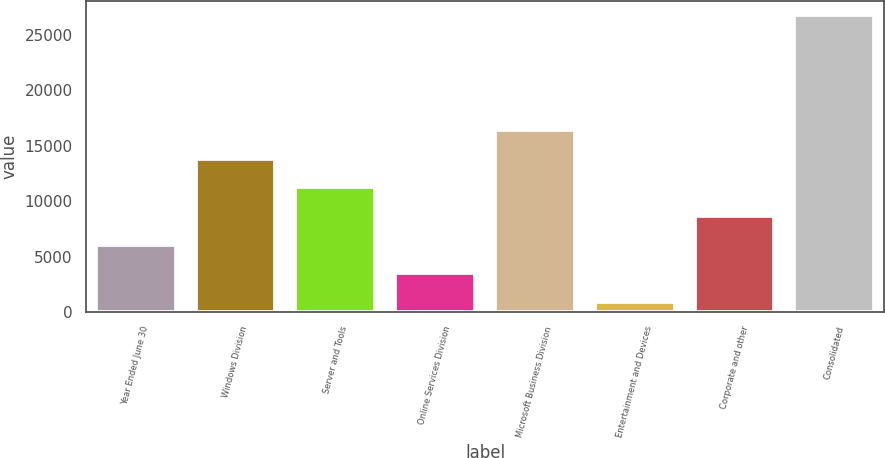Convert chart to OTSL. <chart><loc_0><loc_0><loc_500><loc_500><bar_chart><fcel>Year Ended June 30<fcel>Windows Division<fcel>Server and Tools<fcel>Online Services Division<fcel>Microsoft Business Division<fcel>Entertainment and Devices<fcel>Corporate and other<fcel>Consolidated<nl><fcel>6063.2<fcel>13826<fcel>11238.4<fcel>3475.6<fcel>16413.6<fcel>888<fcel>8650.8<fcel>26764<nl></chart> 